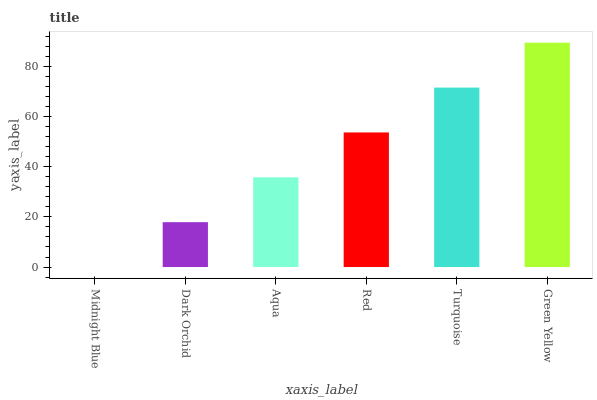Is Midnight Blue the minimum?
Answer yes or no. Yes. Is Green Yellow the maximum?
Answer yes or no. Yes. Is Dark Orchid the minimum?
Answer yes or no. No. Is Dark Orchid the maximum?
Answer yes or no. No. Is Dark Orchid greater than Midnight Blue?
Answer yes or no. Yes. Is Midnight Blue less than Dark Orchid?
Answer yes or no. Yes. Is Midnight Blue greater than Dark Orchid?
Answer yes or no. No. Is Dark Orchid less than Midnight Blue?
Answer yes or no. No. Is Red the high median?
Answer yes or no. Yes. Is Aqua the low median?
Answer yes or no. Yes. Is Turquoise the high median?
Answer yes or no. No. Is Red the low median?
Answer yes or no. No. 